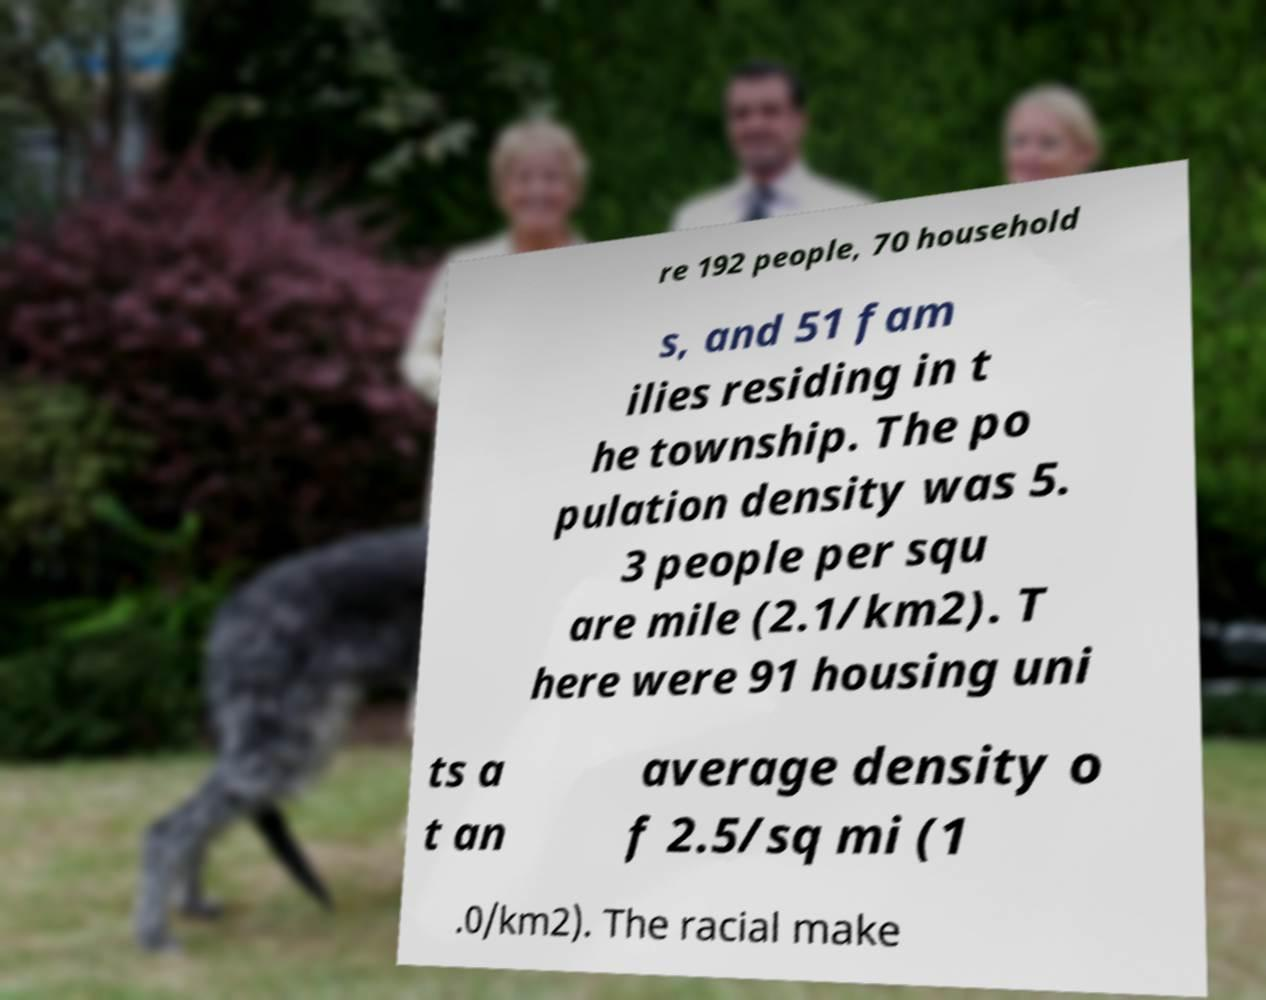Please identify and transcribe the text found in this image. re 192 people, 70 household s, and 51 fam ilies residing in t he township. The po pulation density was 5. 3 people per squ are mile (2.1/km2). T here were 91 housing uni ts a t an average density o f 2.5/sq mi (1 .0/km2). The racial make 